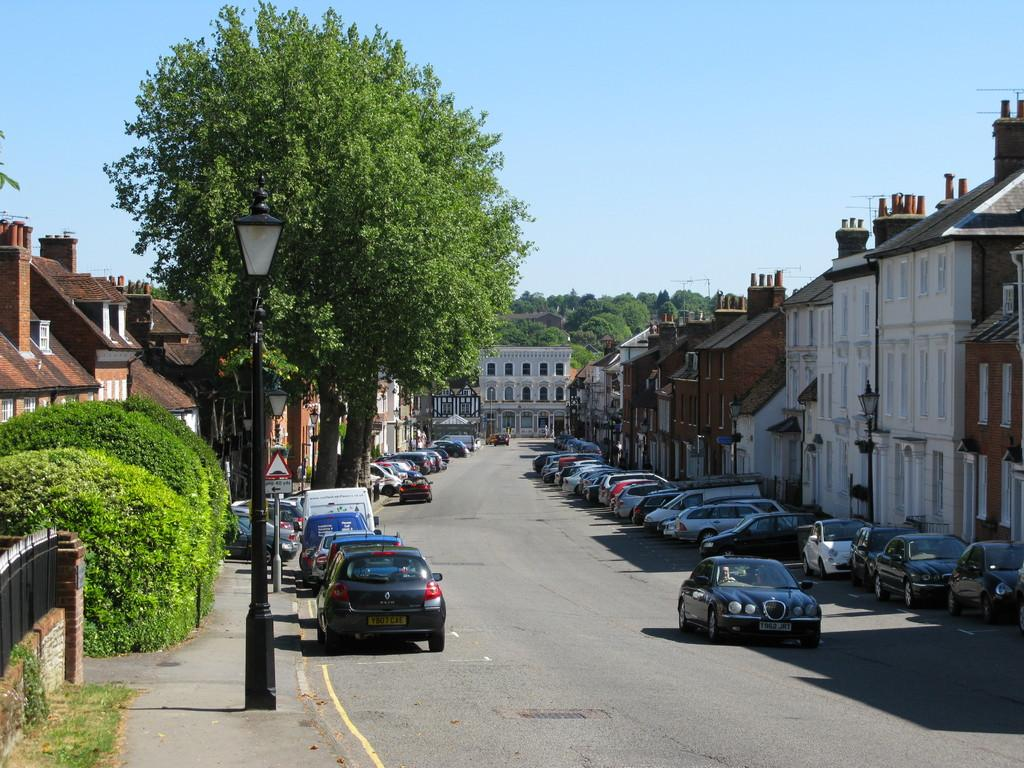What can be seen on the road in the image? There are vehicles on the road in the image. What structures are present along the road? There are light poles in the image. What type of information might be conveyed by the sign board in the image? The sign board in the image might convey information about directions, warnings, or advertisements. What type of barrier is present in the image? There is a fence in the image. What type of vegetation is present in the image? There are trees in the image. What type of structures are visible with windows? There are buildings with windows in the image. What other objects can be seen in the image? There are some objects in the image. What can be seen in the background of the image? The sky is visible in the background of the image. What type of soup is being served in the image? There is no soup present in the image. What type of ear is visible in the image? There is no ear present in the image. 